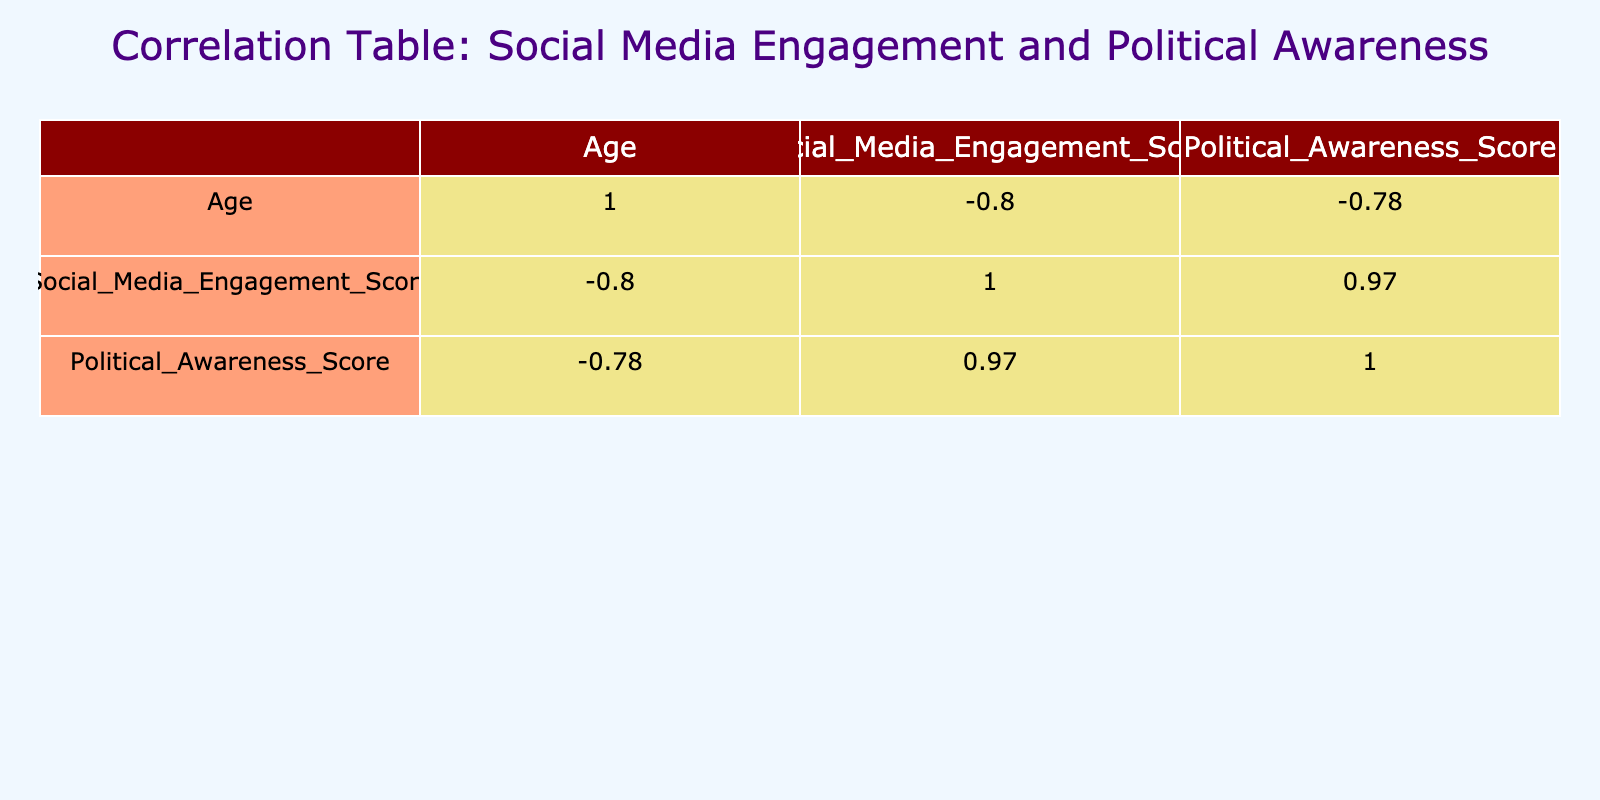What is the correlation coefficient between social media engagement score and political awareness score? The correlation coefficient is found at the intersection of the 'Social Media Engagement Score' and 'Political Awareness Score' rows and columns in the table. It shows a positive correlation.
Answer: 0.87 What is the correlation coefficient between age and political awareness score? This is obtained from the row and column for 'Age' and 'Political Awareness Score'. It indicates a weak positive correlation between these two variables.
Answer: 0.41 Is there a negative correlation between age and social media engagement score? We check the coefficients in the table. The value indicates a weak negative relationship, meaning older individuals tend to engage less on social media.
Answer: Yes What is the average social media engagement score for voters affiliated with the Democratic Party? We find the scores for all Democratic voters: 82, 70, 77, and 80, sum these values (82 + 70 + 77 + 80 = 309) and divide by 4 to find the average, which is 77.25.
Answer: 77.25 Which party affiliation group shows the highest political awareness score on average? First, calculate the average political awareness scores for each party: Democrats have scores of 75, 65, 70, and 75 (average 71.25); Republicans have 60, 55, 63 (average 59.33); Independents have 85, 78, 90, and 75 (average 82.5). Independent voters have the highest average score.
Answer: Independent How many voters have both high social media engagement (above 80) and high political awareness (above 75)? We filter through the table to identify voters with scores above these thresholds. Voter IDs 1, 3, 6, and 9 meet both criteria, resulting in a total of four voters.
Answer: 4 Is the social media engagement score for Independent voters always higher than that of Republican voters? By reviewing the engagement scores of Independent (82, 90, 88, 80) and Republican (65, 50, 68) voters, we can see that all Independents had higher scores than the highest Republican score. Thus, the statement holds true.
Answer: Yes What is the maximum political awareness score observed among the voters in the dataset? From the 'Political Awareness Score' column in the table, by checking all the values (75, 60, 85, 65, 55, 78, 70, 50, 90, 60, 63, 75), we see that the maximum score is 90.
Answer: 90 Which age group seems to have the lowest average social media engagement score? We sort through the ages alongside their engagement scores. The age groups of 50 and 39 have the lowest scores (40 and 50 respectively). Hence, the 50-year age group has the lowest engagement score.
Answer: 50 years old What percentage of voters showed a social media engagement score above 75? First, we find the number of voters with scores above 75: they are Voter IDs 1, 3, 6, 9, and 12 totaling 5, out of 12 total voters. The percentage is (5/12)*100, which yields approximately 41.67%.
Answer: 41.67% 